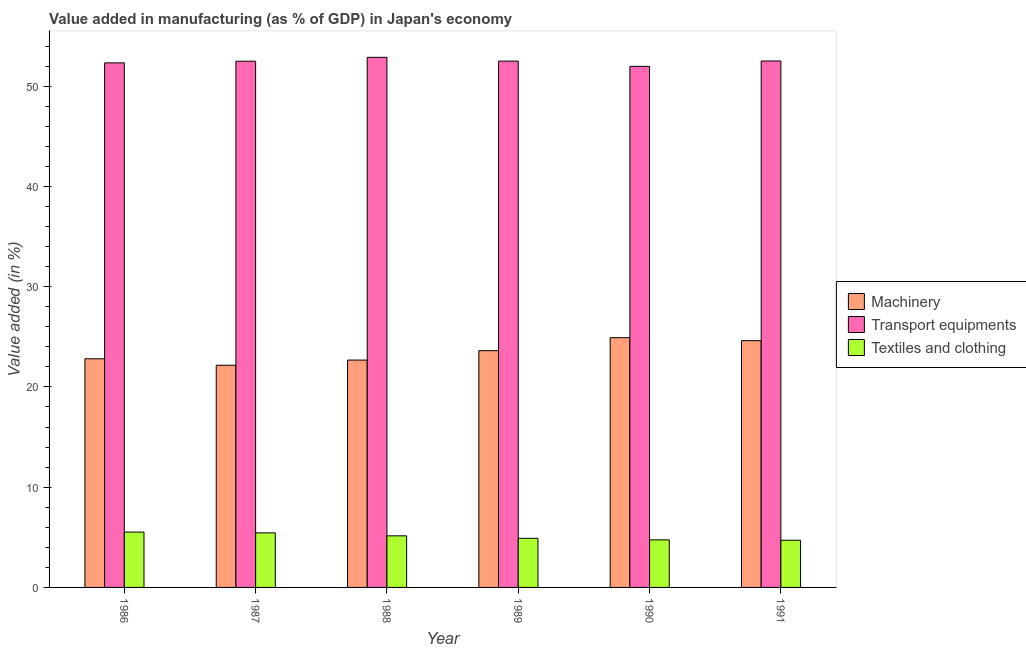Are the number of bars on each tick of the X-axis equal?
Offer a very short reply. Yes. How many bars are there on the 2nd tick from the left?
Provide a short and direct response. 3. How many bars are there on the 3rd tick from the right?
Offer a terse response. 3. What is the label of the 4th group of bars from the left?
Keep it short and to the point. 1989. What is the value added in manufacturing transport equipments in 1989?
Your answer should be very brief. 52.5. Across all years, what is the maximum value added in manufacturing textile and clothing?
Your answer should be very brief. 5.52. Across all years, what is the minimum value added in manufacturing machinery?
Offer a terse response. 22.16. In which year was the value added in manufacturing machinery maximum?
Offer a terse response. 1990. What is the total value added in manufacturing transport equipments in the graph?
Offer a very short reply. 314.67. What is the difference between the value added in manufacturing machinery in 1988 and that in 1991?
Your answer should be very brief. -1.93. What is the difference between the value added in manufacturing textile and clothing in 1989 and the value added in manufacturing transport equipments in 1987?
Keep it short and to the point. -0.54. What is the average value added in manufacturing transport equipments per year?
Provide a succinct answer. 52.45. In how many years, is the value added in manufacturing transport equipments greater than 48 %?
Provide a short and direct response. 6. What is the ratio of the value added in manufacturing textile and clothing in 1988 to that in 1990?
Your response must be concise. 1.08. Is the value added in manufacturing textile and clothing in 1986 less than that in 1987?
Offer a terse response. No. Is the difference between the value added in manufacturing transport equipments in 1986 and 1987 greater than the difference between the value added in manufacturing textile and clothing in 1986 and 1987?
Keep it short and to the point. No. What is the difference between the highest and the second highest value added in manufacturing textile and clothing?
Make the answer very short. 0.08. What is the difference between the highest and the lowest value added in manufacturing transport equipments?
Offer a very short reply. 0.9. What does the 3rd bar from the left in 1990 represents?
Provide a short and direct response. Textiles and clothing. What does the 2nd bar from the right in 1991 represents?
Give a very brief answer. Transport equipments. How many years are there in the graph?
Give a very brief answer. 6. Are the values on the major ticks of Y-axis written in scientific E-notation?
Ensure brevity in your answer.  No. What is the title of the graph?
Your answer should be very brief. Value added in manufacturing (as % of GDP) in Japan's economy. Does "Agricultural raw materials" appear as one of the legend labels in the graph?
Provide a short and direct response. No. What is the label or title of the Y-axis?
Give a very brief answer. Value added (in %). What is the Value added (in %) in Machinery in 1986?
Give a very brief answer. 22.81. What is the Value added (in %) of Transport equipments in 1986?
Your answer should be very brief. 52.32. What is the Value added (in %) in Textiles and clothing in 1986?
Provide a succinct answer. 5.52. What is the Value added (in %) in Machinery in 1987?
Provide a short and direct response. 22.16. What is the Value added (in %) of Transport equipments in 1987?
Give a very brief answer. 52.49. What is the Value added (in %) in Textiles and clothing in 1987?
Provide a short and direct response. 5.44. What is the Value added (in %) of Machinery in 1988?
Your answer should be very brief. 22.68. What is the Value added (in %) of Transport equipments in 1988?
Your answer should be very brief. 52.88. What is the Value added (in %) in Textiles and clothing in 1988?
Your answer should be compact. 5.15. What is the Value added (in %) in Machinery in 1989?
Offer a terse response. 23.61. What is the Value added (in %) in Transport equipments in 1989?
Ensure brevity in your answer.  52.5. What is the Value added (in %) in Textiles and clothing in 1989?
Make the answer very short. 4.9. What is the Value added (in %) in Machinery in 1990?
Make the answer very short. 24.91. What is the Value added (in %) in Transport equipments in 1990?
Keep it short and to the point. 51.97. What is the Value added (in %) in Textiles and clothing in 1990?
Give a very brief answer. 4.74. What is the Value added (in %) of Machinery in 1991?
Make the answer very short. 24.61. What is the Value added (in %) in Transport equipments in 1991?
Keep it short and to the point. 52.51. What is the Value added (in %) in Textiles and clothing in 1991?
Make the answer very short. 4.7. Across all years, what is the maximum Value added (in %) of Machinery?
Keep it short and to the point. 24.91. Across all years, what is the maximum Value added (in %) of Transport equipments?
Offer a very short reply. 52.88. Across all years, what is the maximum Value added (in %) in Textiles and clothing?
Offer a terse response. 5.52. Across all years, what is the minimum Value added (in %) in Machinery?
Make the answer very short. 22.16. Across all years, what is the minimum Value added (in %) of Transport equipments?
Ensure brevity in your answer.  51.97. Across all years, what is the minimum Value added (in %) in Textiles and clothing?
Offer a terse response. 4.7. What is the total Value added (in %) in Machinery in the graph?
Your answer should be compact. 140.78. What is the total Value added (in %) of Transport equipments in the graph?
Make the answer very short. 314.67. What is the total Value added (in %) in Textiles and clothing in the graph?
Keep it short and to the point. 30.45. What is the difference between the Value added (in %) in Machinery in 1986 and that in 1987?
Give a very brief answer. 0.65. What is the difference between the Value added (in %) of Transport equipments in 1986 and that in 1987?
Ensure brevity in your answer.  -0.17. What is the difference between the Value added (in %) of Textiles and clothing in 1986 and that in 1987?
Make the answer very short. 0.08. What is the difference between the Value added (in %) in Machinery in 1986 and that in 1988?
Offer a very short reply. 0.13. What is the difference between the Value added (in %) of Transport equipments in 1986 and that in 1988?
Offer a terse response. -0.55. What is the difference between the Value added (in %) of Textiles and clothing in 1986 and that in 1988?
Provide a succinct answer. 0.37. What is the difference between the Value added (in %) in Machinery in 1986 and that in 1989?
Give a very brief answer. -0.81. What is the difference between the Value added (in %) of Transport equipments in 1986 and that in 1989?
Make the answer very short. -0.17. What is the difference between the Value added (in %) in Textiles and clothing in 1986 and that in 1989?
Your answer should be compact. 0.62. What is the difference between the Value added (in %) in Machinery in 1986 and that in 1990?
Your response must be concise. -2.1. What is the difference between the Value added (in %) of Transport equipments in 1986 and that in 1990?
Offer a very short reply. 0.35. What is the difference between the Value added (in %) in Textiles and clothing in 1986 and that in 1990?
Your response must be concise. 0.78. What is the difference between the Value added (in %) of Machinery in 1986 and that in 1991?
Offer a terse response. -1.8. What is the difference between the Value added (in %) in Transport equipments in 1986 and that in 1991?
Keep it short and to the point. -0.19. What is the difference between the Value added (in %) of Textiles and clothing in 1986 and that in 1991?
Your answer should be compact. 0.82. What is the difference between the Value added (in %) of Machinery in 1987 and that in 1988?
Offer a terse response. -0.52. What is the difference between the Value added (in %) of Transport equipments in 1987 and that in 1988?
Provide a short and direct response. -0.39. What is the difference between the Value added (in %) of Textiles and clothing in 1987 and that in 1988?
Make the answer very short. 0.29. What is the difference between the Value added (in %) of Machinery in 1987 and that in 1989?
Your answer should be very brief. -1.45. What is the difference between the Value added (in %) in Transport equipments in 1987 and that in 1989?
Your answer should be compact. -0.01. What is the difference between the Value added (in %) in Textiles and clothing in 1987 and that in 1989?
Your answer should be compact. 0.54. What is the difference between the Value added (in %) in Machinery in 1987 and that in 1990?
Your answer should be compact. -2.75. What is the difference between the Value added (in %) in Transport equipments in 1987 and that in 1990?
Ensure brevity in your answer.  0.52. What is the difference between the Value added (in %) in Textiles and clothing in 1987 and that in 1990?
Your answer should be compact. 0.7. What is the difference between the Value added (in %) of Machinery in 1987 and that in 1991?
Offer a very short reply. -2.45. What is the difference between the Value added (in %) of Transport equipments in 1987 and that in 1991?
Your answer should be compact. -0.02. What is the difference between the Value added (in %) in Textiles and clothing in 1987 and that in 1991?
Ensure brevity in your answer.  0.74. What is the difference between the Value added (in %) of Machinery in 1988 and that in 1989?
Provide a succinct answer. -0.94. What is the difference between the Value added (in %) in Transport equipments in 1988 and that in 1989?
Make the answer very short. 0.38. What is the difference between the Value added (in %) of Textiles and clothing in 1988 and that in 1989?
Provide a short and direct response. 0.25. What is the difference between the Value added (in %) in Machinery in 1988 and that in 1990?
Your answer should be compact. -2.23. What is the difference between the Value added (in %) of Transport equipments in 1988 and that in 1990?
Keep it short and to the point. 0.9. What is the difference between the Value added (in %) in Textiles and clothing in 1988 and that in 1990?
Make the answer very short. 0.4. What is the difference between the Value added (in %) in Machinery in 1988 and that in 1991?
Your response must be concise. -1.93. What is the difference between the Value added (in %) in Transport equipments in 1988 and that in 1991?
Ensure brevity in your answer.  0.37. What is the difference between the Value added (in %) in Textiles and clothing in 1988 and that in 1991?
Make the answer very short. 0.44. What is the difference between the Value added (in %) of Machinery in 1989 and that in 1990?
Keep it short and to the point. -1.3. What is the difference between the Value added (in %) in Transport equipments in 1989 and that in 1990?
Provide a short and direct response. 0.52. What is the difference between the Value added (in %) in Textiles and clothing in 1989 and that in 1990?
Give a very brief answer. 0.15. What is the difference between the Value added (in %) of Machinery in 1989 and that in 1991?
Offer a terse response. -1. What is the difference between the Value added (in %) in Transport equipments in 1989 and that in 1991?
Make the answer very short. -0.01. What is the difference between the Value added (in %) of Textiles and clothing in 1989 and that in 1991?
Provide a succinct answer. 0.19. What is the difference between the Value added (in %) in Machinery in 1990 and that in 1991?
Offer a terse response. 0.3. What is the difference between the Value added (in %) of Transport equipments in 1990 and that in 1991?
Provide a short and direct response. -0.54. What is the difference between the Value added (in %) in Textiles and clothing in 1990 and that in 1991?
Offer a very short reply. 0.04. What is the difference between the Value added (in %) of Machinery in 1986 and the Value added (in %) of Transport equipments in 1987?
Give a very brief answer. -29.68. What is the difference between the Value added (in %) of Machinery in 1986 and the Value added (in %) of Textiles and clothing in 1987?
Give a very brief answer. 17.37. What is the difference between the Value added (in %) of Transport equipments in 1986 and the Value added (in %) of Textiles and clothing in 1987?
Offer a very short reply. 46.88. What is the difference between the Value added (in %) in Machinery in 1986 and the Value added (in %) in Transport equipments in 1988?
Give a very brief answer. -30.07. What is the difference between the Value added (in %) of Machinery in 1986 and the Value added (in %) of Textiles and clothing in 1988?
Your answer should be compact. 17.66. What is the difference between the Value added (in %) of Transport equipments in 1986 and the Value added (in %) of Textiles and clothing in 1988?
Provide a succinct answer. 47.18. What is the difference between the Value added (in %) of Machinery in 1986 and the Value added (in %) of Transport equipments in 1989?
Provide a succinct answer. -29.69. What is the difference between the Value added (in %) in Machinery in 1986 and the Value added (in %) in Textiles and clothing in 1989?
Your answer should be compact. 17.91. What is the difference between the Value added (in %) of Transport equipments in 1986 and the Value added (in %) of Textiles and clothing in 1989?
Provide a short and direct response. 47.43. What is the difference between the Value added (in %) in Machinery in 1986 and the Value added (in %) in Transport equipments in 1990?
Your answer should be compact. -29.17. What is the difference between the Value added (in %) in Machinery in 1986 and the Value added (in %) in Textiles and clothing in 1990?
Ensure brevity in your answer.  18.06. What is the difference between the Value added (in %) of Transport equipments in 1986 and the Value added (in %) of Textiles and clothing in 1990?
Offer a very short reply. 47.58. What is the difference between the Value added (in %) of Machinery in 1986 and the Value added (in %) of Transport equipments in 1991?
Offer a very short reply. -29.7. What is the difference between the Value added (in %) in Machinery in 1986 and the Value added (in %) in Textiles and clothing in 1991?
Your answer should be compact. 18.1. What is the difference between the Value added (in %) in Transport equipments in 1986 and the Value added (in %) in Textiles and clothing in 1991?
Provide a short and direct response. 47.62. What is the difference between the Value added (in %) in Machinery in 1987 and the Value added (in %) in Transport equipments in 1988?
Ensure brevity in your answer.  -30.71. What is the difference between the Value added (in %) in Machinery in 1987 and the Value added (in %) in Textiles and clothing in 1988?
Provide a succinct answer. 17.01. What is the difference between the Value added (in %) of Transport equipments in 1987 and the Value added (in %) of Textiles and clothing in 1988?
Your answer should be very brief. 47.34. What is the difference between the Value added (in %) in Machinery in 1987 and the Value added (in %) in Transport equipments in 1989?
Give a very brief answer. -30.34. What is the difference between the Value added (in %) of Machinery in 1987 and the Value added (in %) of Textiles and clothing in 1989?
Give a very brief answer. 17.26. What is the difference between the Value added (in %) in Transport equipments in 1987 and the Value added (in %) in Textiles and clothing in 1989?
Offer a terse response. 47.59. What is the difference between the Value added (in %) of Machinery in 1987 and the Value added (in %) of Transport equipments in 1990?
Provide a succinct answer. -29.81. What is the difference between the Value added (in %) in Machinery in 1987 and the Value added (in %) in Textiles and clothing in 1990?
Ensure brevity in your answer.  17.42. What is the difference between the Value added (in %) in Transport equipments in 1987 and the Value added (in %) in Textiles and clothing in 1990?
Make the answer very short. 47.75. What is the difference between the Value added (in %) in Machinery in 1987 and the Value added (in %) in Transport equipments in 1991?
Offer a very short reply. -30.35. What is the difference between the Value added (in %) of Machinery in 1987 and the Value added (in %) of Textiles and clothing in 1991?
Give a very brief answer. 17.46. What is the difference between the Value added (in %) in Transport equipments in 1987 and the Value added (in %) in Textiles and clothing in 1991?
Provide a short and direct response. 47.79. What is the difference between the Value added (in %) in Machinery in 1988 and the Value added (in %) in Transport equipments in 1989?
Offer a very short reply. -29.82. What is the difference between the Value added (in %) in Machinery in 1988 and the Value added (in %) in Textiles and clothing in 1989?
Provide a short and direct response. 17.78. What is the difference between the Value added (in %) in Transport equipments in 1988 and the Value added (in %) in Textiles and clothing in 1989?
Offer a terse response. 47.98. What is the difference between the Value added (in %) in Machinery in 1988 and the Value added (in %) in Transport equipments in 1990?
Provide a short and direct response. -29.3. What is the difference between the Value added (in %) in Machinery in 1988 and the Value added (in %) in Textiles and clothing in 1990?
Ensure brevity in your answer.  17.93. What is the difference between the Value added (in %) in Transport equipments in 1988 and the Value added (in %) in Textiles and clothing in 1990?
Keep it short and to the point. 48.13. What is the difference between the Value added (in %) of Machinery in 1988 and the Value added (in %) of Transport equipments in 1991?
Ensure brevity in your answer.  -29.83. What is the difference between the Value added (in %) of Machinery in 1988 and the Value added (in %) of Textiles and clothing in 1991?
Ensure brevity in your answer.  17.97. What is the difference between the Value added (in %) in Transport equipments in 1988 and the Value added (in %) in Textiles and clothing in 1991?
Ensure brevity in your answer.  48.17. What is the difference between the Value added (in %) in Machinery in 1989 and the Value added (in %) in Transport equipments in 1990?
Your response must be concise. -28.36. What is the difference between the Value added (in %) of Machinery in 1989 and the Value added (in %) of Textiles and clothing in 1990?
Offer a terse response. 18.87. What is the difference between the Value added (in %) of Transport equipments in 1989 and the Value added (in %) of Textiles and clothing in 1990?
Your response must be concise. 47.75. What is the difference between the Value added (in %) of Machinery in 1989 and the Value added (in %) of Transport equipments in 1991?
Your response must be concise. -28.9. What is the difference between the Value added (in %) of Machinery in 1989 and the Value added (in %) of Textiles and clothing in 1991?
Provide a succinct answer. 18.91. What is the difference between the Value added (in %) in Transport equipments in 1989 and the Value added (in %) in Textiles and clothing in 1991?
Your answer should be compact. 47.79. What is the difference between the Value added (in %) of Machinery in 1990 and the Value added (in %) of Transport equipments in 1991?
Your response must be concise. -27.6. What is the difference between the Value added (in %) in Machinery in 1990 and the Value added (in %) in Textiles and clothing in 1991?
Make the answer very short. 20.21. What is the difference between the Value added (in %) in Transport equipments in 1990 and the Value added (in %) in Textiles and clothing in 1991?
Offer a very short reply. 47.27. What is the average Value added (in %) in Machinery per year?
Keep it short and to the point. 23.46. What is the average Value added (in %) in Transport equipments per year?
Your response must be concise. 52.45. What is the average Value added (in %) of Textiles and clothing per year?
Keep it short and to the point. 5.08. In the year 1986, what is the difference between the Value added (in %) of Machinery and Value added (in %) of Transport equipments?
Ensure brevity in your answer.  -29.52. In the year 1986, what is the difference between the Value added (in %) of Machinery and Value added (in %) of Textiles and clothing?
Your answer should be very brief. 17.29. In the year 1986, what is the difference between the Value added (in %) of Transport equipments and Value added (in %) of Textiles and clothing?
Give a very brief answer. 46.8. In the year 1987, what is the difference between the Value added (in %) in Machinery and Value added (in %) in Transport equipments?
Your answer should be very brief. -30.33. In the year 1987, what is the difference between the Value added (in %) in Machinery and Value added (in %) in Textiles and clothing?
Provide a short and direct response. 16.72. In the year 1987, what is the difference between the Value added (in %) of Transport equipments and Value added (in %) of Textiles and clothing?
Your answer should be compact. 47.05. In the year 1988, what is the difference between the Value added (in %) in Machinery and Value added (in %) in Transport equipments?
Provide a succinct answer. -30.2. In the year 1988, what is the difference between the Value added (in %) of Machinery and Value added (in %) of Textiles and clothing?
Keep it short and to the point. 17.53. In the year 1988, what is the difference between the Value added (in %) of Transport equipments and Value added (in %) of Textiles and clothing?
Keep it short and to the point. 47.73. In the year 1989, what is the difference between the Value added (in %) of Machinery and Value added (in %) of Transport equipments?
Offer a very short reply. -28.88. In the year 1989, what is the difference between the Value added (in %) in Machinery and Value added (in %) in Textiles and clothing?
Keep it short and to the point. 18.72. In the year 1989, what is the difference between the Value added (in %) of Transport equipments and Value added (in %) of Textiles and clothing?
Ensure brevity in your answer.  47.6. In the year 1990, what is the difference between the Value added (in %) of Machinery and Value added (in %) of Transport equipments?
Provide a short and direct response. -27.06. In the year 1990, what is the difference between the Value added (in %) of Machinery and Value added (in %) of Textiles and clothing?
Provide a succinct answer. 20.17. In the year 1990, what is the difference between the Value added (in %) in Transport equipments and Value added (in %) in Textiles and clothing?
Your answer should be very brief. 47.23. In the year 1991, what is the difference between the Value added (in %) in Machinery and Value added (in %) in Transport equipments?
Give a very brief answer. -27.9. In the year 1991, what is the difference between the Value added (in %) of Machinery and Value added (in %) of Textiles and clothing?
Offer a very short reply. 19.91. In the year 1991, what is the difference between the Value added (in %) of Transport equipments and Value added (in %) of Textiles and clothing?
Ensure brevity in your answer.  47.81. What is the ratio of the Value added (in %) in Machinery in 1986 to that in 1987?
Make the answer very short. 1.03. What is the ratio of the Value added (in %) in Textiles and clothing in 1986 to that in 1987?
Ensure brevity in your answer.  1.01. What is the ratio of the Value added (in %) of Transport equipments in 1986 to that in 1988?
Your answer should be compact. 0.99. What is the ratio of the Value added (in %) of Textiles and clothing in 1986 to that in 1988?
Provide a succinct answer. 1.07. What is the ratio of the Value added (in %) in Machinery in 1986 to that in 1989?
Make the answer very short. 0.97. What is the ratio of the Value added (in %) of Textiles and clothing in 1986 to that in 1989?
Provide a short and direct response. 1.13. What is the ratio of the Value added (in %) in Machinery in 1986 to that in 1990?
Give a very brief answer. 0.92. What is the ratio of the Value added (in %) in Transport equipments in 1986 to that in 1990?
Offer a terse response. 1.01. What is the ratio of the Value added (in %) in Textiles and clothing in 1986 to that in 1990?
Provide a succinct answer. 1.16. What is the ratio of the Value added (in %) of Machinery in 1986 to that in 1991?
Provide a succinct answer. 0.93. What is the ratio of the Value added (in %) in Textiles and clothing in 1986 to that in 1991?
Offer a terse response. 1.17. What is the ratio of the Value added (in %) in Machinery in 1987 to that in 1988?
Keep it short and to the point. 0.98. What is the ratio of the Value added (in %) in Textiles and clothing in 1987 to that in 1988?
Your answer should be very brief. 1.06. What is the ratio of the Value added (in %) of Machinery in 1987 to that in 1989?
Make the answer very short. 0.94. What is the ratio of the Value added (in %) of Transport equipments in 1987 to that in 1989?
Keep it short and to the point. 1. What is the ratio of the Value added (in %) of Textiles and clothing in 1987 to that in 1989?
Provide a short and direct response. 1.11. What is the ratio of the Value added (in %) of Machinery in 1987 to that in 1990?
Your response must be concise. 0.89. What is the ratio of the Value added (in %) of Transport equipments in 1987 to that in 1990?
Ensure brevity in your answer.  1.01. What is the ratio of the Value added (in %) in Textiles and clothing in 1987 to that in 1990?
Keep it short and to the point. 1.15. What is the ratio of the Value added (in %) of Machinery in 1987 to that in 1991?
Keep it short and to the point. 0.9. What is the ratio of the Value added (in %) of Transport equipments in 1987 to that in 1991?
Give a very brief answer. 1. What is the ratio of the Value added (in %) of Textiles and clothing in 1987 to that in 1991?
Your answer should be very brief. 1.16. What is the ratio of the Value added (in %) in Machinery in 1988 to that in 1989?
Offer a terse response. 0.96. What is the ratio of the Value added (in %) in Textiles and clothing in 1988 to that in 1989?
Ensure brevity in your answer.  1.05. What is the ratio of the Value added (in %) of Machinery in 1988 to that in 1990?
Provide a short and direct response. 0.91. What is the ratio of the Value added (in %) of Transport equipments in 1988 to that in 1990?
Keep it short and to the point. 1.02. What is the ratio of the Value added (in %) in Textiles and clothing in 1988 to that in 1990?
Your answer should be very brief. 1.08. What is the ratio of the Value added (in %) of Machinery in 1988 to that in 1991?
Provide a short and direct response. 0.92. What is the ratio of the Value added (in %) in Textiles and clothing in 1988 to that in 1991?
Ensure brevity in your answer.  1.09. What is the ratio of the Value added (in %) of Machinery in 1989 to that in 1990?
Give a very brief answer. 0.95. What is the ratio of the Value added (in %) of Textiles and clothing in 1989 to that in 1990?
Ensure brevity in your answer.  1.03. What is the ratio of the Value added (in %) of Machinery in 1989 to that in 1991?
Provide a short and direct response. 0.96. What is the ratio of the Value added (in %) in Textiles and clothing in 1989 to that in 1991?
Your answer should be compact. 1.04. What is the ratio of the Value added (in %) of Machinery in 1990 to that in 1991?
Keep it short and to the point. 1.01. What is the ratio of the Value added (in %) of Textiles and clothing in 1990 to that in 1991?
Ensure brevity in your answer.  1.01. What is the difference between the highest and the second highest Value added (in %) in Machinery?
Your response must be concise. 0.3. What is the difference between the highest and the second highest Value added (in %) of Transport equipments?
Keep it short and to the point. 0.37. What is the difference between the highest and the second highest Value added (in %) in Textiles and clothing?
Your answer should be compact. 0.08. What is the difference between the highest and the lowest Value added (in %) in Machinery?
Your answer should be very brief. 2.75. What is the difference between the highest and the lowest Value added (in %) of Transport equipments?
Your answer should be very brief. 0.9. What is the difference between the highest and the lowest Value added (in %) of Textiles and clothing?
Offer a very short reply. 0.82. 